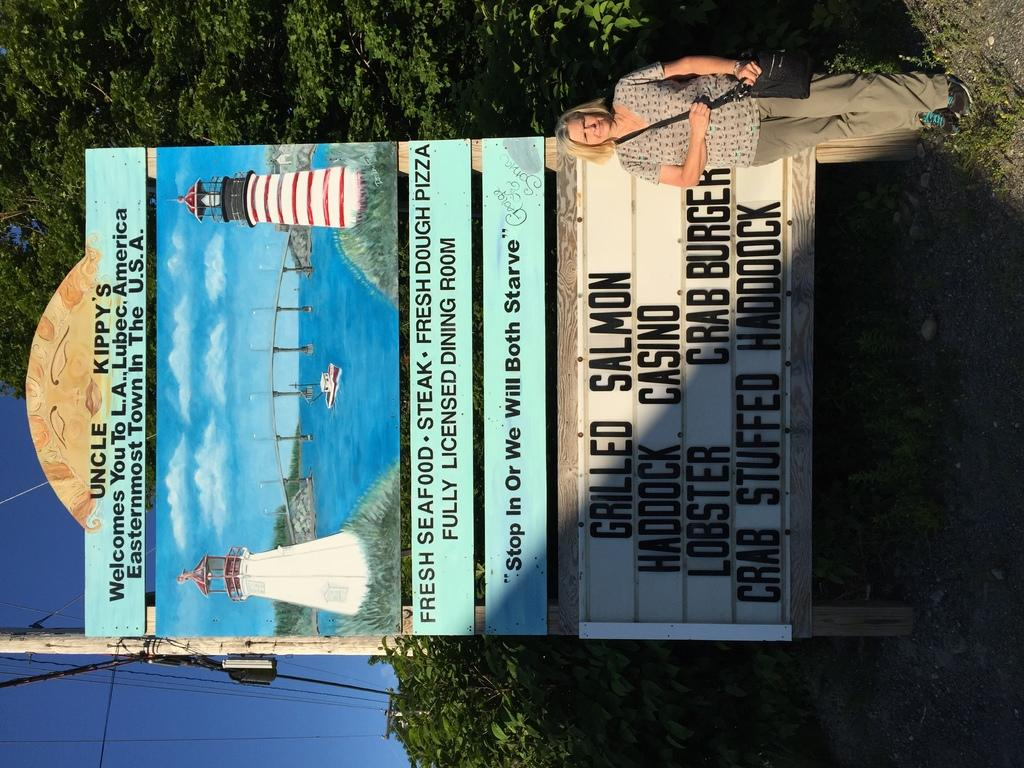<image>
Create a compact narrative representing the image presented. A sign for Uncle Kippy's advertising seafood and a woman standing by the sign. 